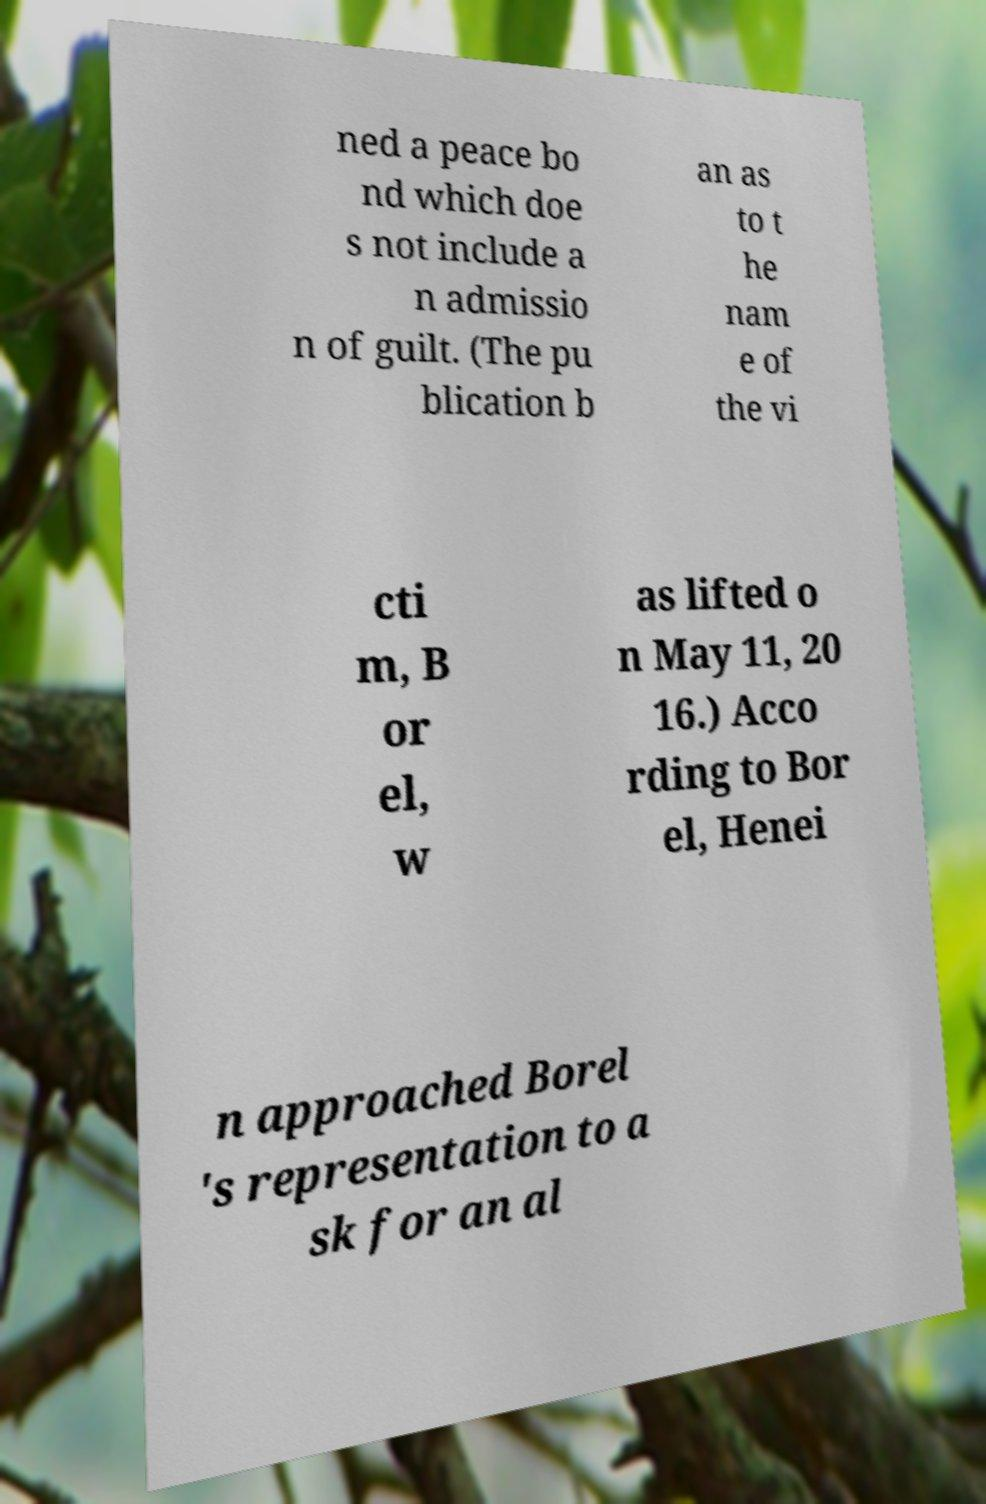What messages or text are displayed in this image? I need them in a readable, typed format. ned a peace bo nd which doe s not include a n admissio n of guilt. (The pu blication b an as to t he nam e of the vi cti m, B or el, w as lifted o n May 11, 20 16.) Acco rding to Bor el, Henei n approached Borel 's representation to a sk for an al 